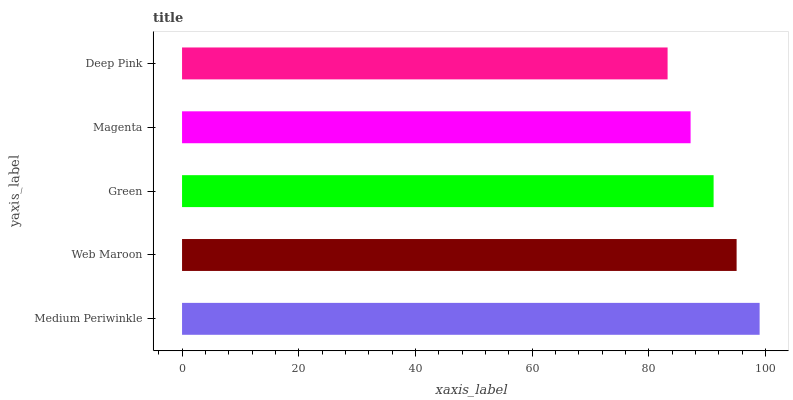Is Deep Pink the minimum?
Answer yes or no. Yes. Is Medium Periwinkle the maximum?
Answer yes or no. Yes. Is Web Maroon the minimum?
Answer yes or no. No. Is Web Maroon the maximum?
Answer yes or no. No. Is Medium Periwinkle greater than Web Maroon?
Answer yes or no. Yes. Is Web Maroon less than Medium Periwinkle?
Answer yes or no. Yes. Is Web Maroon greater than Medium Periwinkle?
Answer yes or no. No. Is Medium Periwinkle less than Web Maroon?
Answer yes or no. No. Is Green the high median?
Answer yes or no. Yes. Is Green the low median?
Answer yes or no. Yes. Is Magenta the high median?
Answer yes or no. No. Is Magenta the low median?
Answer yes or no. No. 